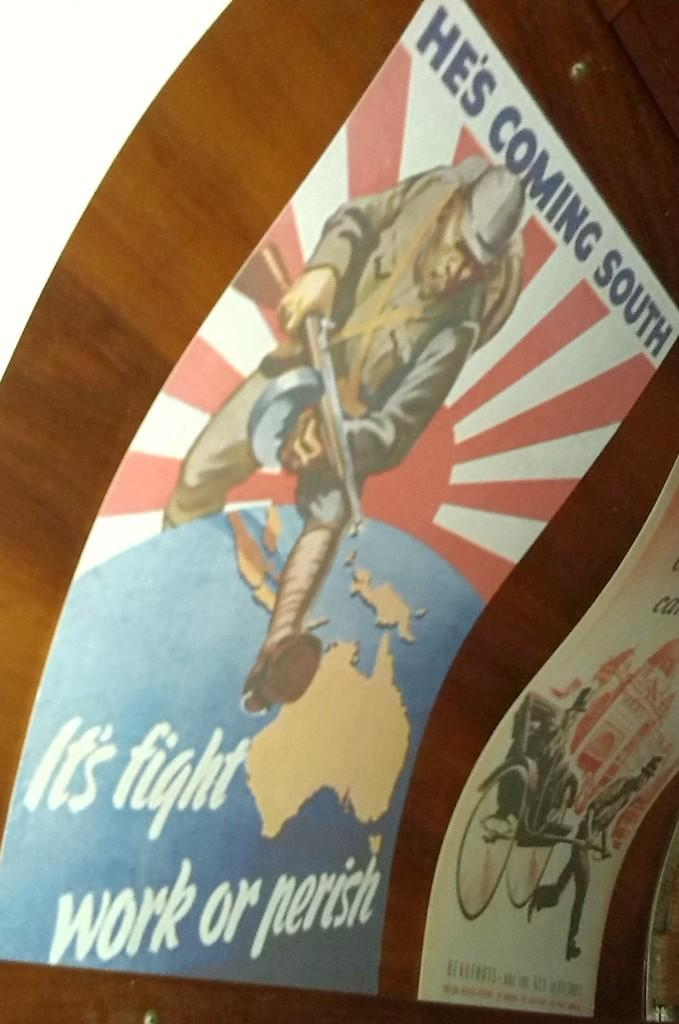What is present on the wooden surface in the image? There are posters on the wooden surface in the image. What can be seen on the posters? The posters contain depictions of persons and some text. Can you see any fog in the image? There is no fog present in the image. What type of machine is depicted on the posters? There is no machine depicted on the posters; they contain depictions of persons. 